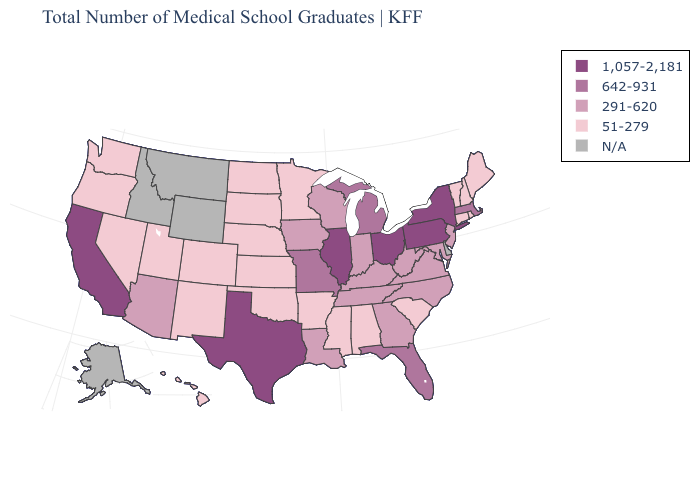What is the highest value in the USA?
Write a very short answer. 1,057-2,181. What is the value of New York?
Answer briefly. 1,057-2,181. Does Nevada have the highest value in the West?
Be succinct. No. Does Rhode Island have the highest value in the Northeast?
Write a very short answer. No. Name the states that have a value in the range 642-931?
Short answer required. Florida, Massachusetts, Michigan, Missouri. Name the states that have a value in the range 291-620?
Be succinct. Arizona, Georgia, Indiana, Iowa, Kentucky, Louisiana, Maryland, New Jersey, North Carolina, Tennessee, Virginia, West Virginia, Wisconsin. What is the highest value in the USA?
Quick response, please. 1,057-2,181. Is the legend a continuous bar?
Answer briefly. No. What is the lowest value in states that border Connecticut?
Give a very brief answer. 51-279. What is the value of Nevada?
Answer briefly. 51-279. Name the states that have a value in the range 642-931?
Answer briefly. Florida, Massachusetts, Michigan, Missouri. Name the states that have a value in the range 291-620?
Quick response, please. Arizona, Georgia, Indiana, Iowa, Kentucky, Louisiana, Maryland, New Jersey, North Carolina, Tennessee, Virginia, West Virginia, Wisconsin. Which states hav the highest value in the West?
Answer briefly. California. 